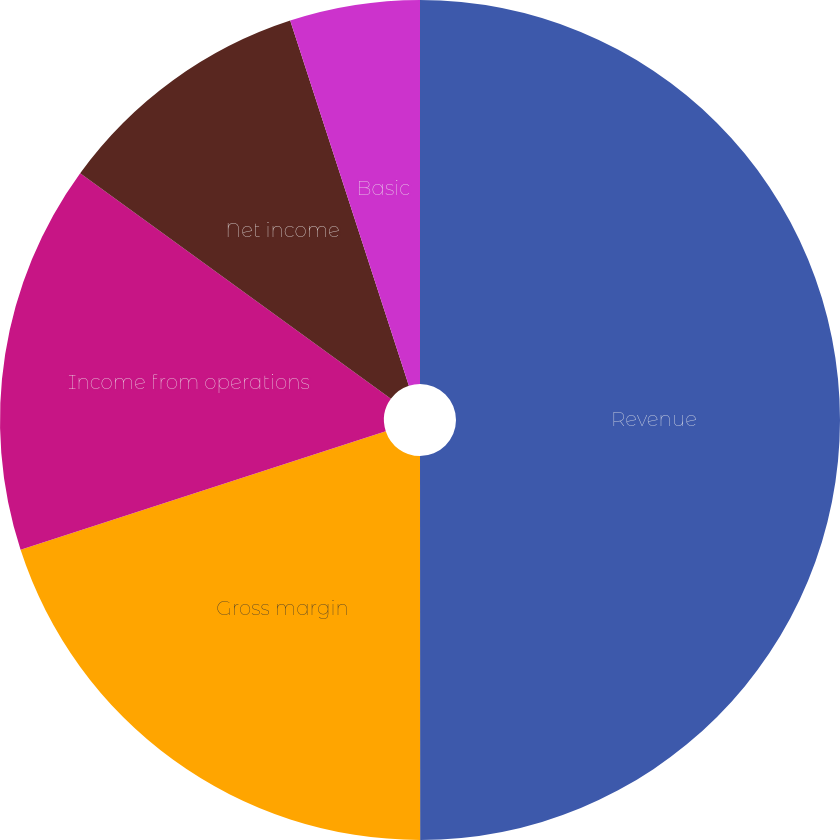Convert chart. <chart><loc_0><loc_0><loc_500><loc_500><pie_chart><fcel>Revenue<fcel>Gross margin<fcel>Income from operations<fcel>Net income<fcel>Basic<fcel>Diluted<nl><fcel>49.99%<fcel>20.0%<fcel>15.0%<fcel>10.0%<fcel>5.0%<fcel>0.0%<nl></chart> 